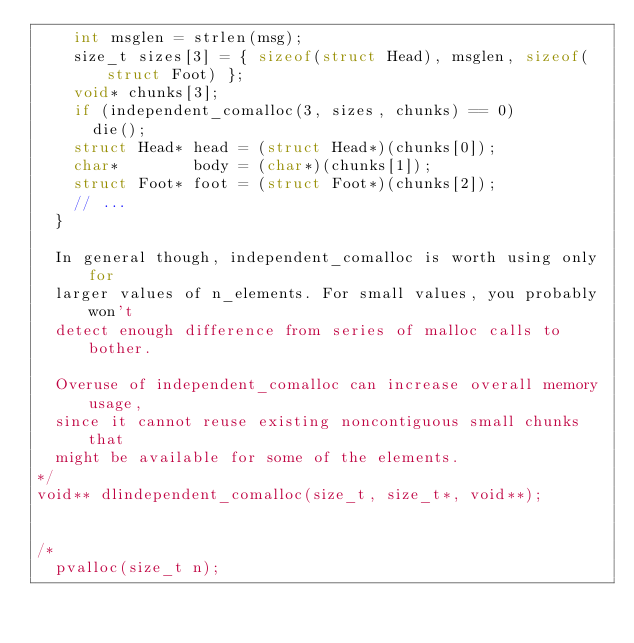Convert code to text. <code><loc_0><loc_0><loc_500><loc_500><_C_>    int msglen = strlen(msg);
    size_t sizes[3] = { sizeof(struct Head), msglen, sizeof(struct Foot) };
    void* chunks[3];
    if (independent_comalloc(3, sizes, chunks) == 0)
      die();
    struct Head* head = (struct Head*)(chunks[0]);
    char*        body = (char*)(chunks[1]);
    struct Foot* foot = (struct Foot*)(chunks[2]);
    // ...
  }

  In general though, independent_comalloc is worth using only for
  larger values of n_elements. For small values, you probably won't
  detect enough difference from series of malloc calls to bother.

  Overuse of independent_comalloc can increase overall memory usage,
  since it cannot reuse existing noncontiguous small chunks that
  might be available for some of the elements.
*/
void** dlindependent_comalloc(size_t, size_t*, void**);


/*
  pvalloc(size_t n);</code> 